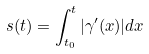<formula> <loc_0><loc_0><loc_500><loc_500>s ( t ) = \int _ { t _ { 0 } } ^ { t } | \gamma ^ { \prime } ( x ) | d x</formula> 